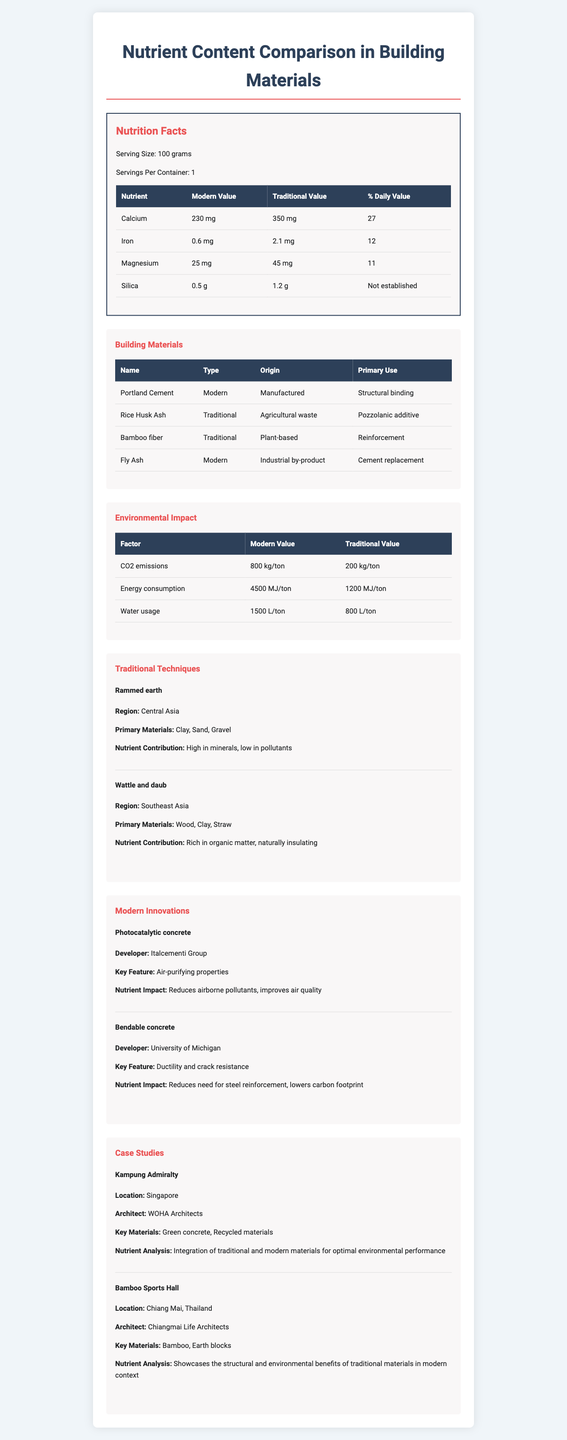what is the serving size mentioned in the document? The serving size is explicitly listed as "100 grams" in the Nutrition Facts section of the document.
Answer: 100 grams how many nutrients are compared between modern and traditional building materials? The document lists Calcium, Iron, Magnesium, and Silica in the Nutrition Facts section, making a total of four nutrients.
Answer: Four which traditional technique is high in minerals and low in pollutants? The Traditional Techniques section describes Rammed earth as high in minerals and low in pollutants.
Answer: Rammed earth what is the primary use of Portland Cement? The Building Materials section states that Portland Cement's primary use is for structural binding.
Answer: Structural binding how does photocatalytic concrete impact nutrients? The Modern Innovations section describes photocatalytic concrete's nutrient impact as reducing airborne pollutants and improving air quality.
Answer: Reduces airborne pollutants, improves air quality what are the primary materials used in the wattle and daub technique? A. Clay, Sand, Gravel B. Wood, Clay, Straw C. Straw, Sand, Earth D. Bamboo, Earth, Metal The Traditional Techniques section lists Wood, Clay, and Straw as the primary materials for the wattle and daub technique.
Answer: B. Wood, Clay, Straw what is the environmental impact of traditional materials concerning CO2 emissions? A. 800 kg/ton B. 4500 MJ/ton C. 1200 kg/ton D. 200 kg/ton The Environmental Impact section lists 200 kg/ton as the CO2 emissions value for traditional materials.
Answer: D. 200 kg/ton is fly ash considered a modern or traditional building material? The Building Materials section categorizes Fly Ash as a modern building material.
Answer: Modern does the document provide specific nutrient values for the case studies' key materials? The Case Studies section does not provide specific nutrient values for the key materials used; it focuses on the general analysis and integration of traditional and modern materials.
Answer: No summarize the main idea of the document. The document offers an in-depth look at the nutrient content and environmental impact of both modern and traditional building materials. It lists detailed nutrient values, origins, and uses of several materials, compares environmental impacts, examines traditional building techniques, modern innovations, and includes case studies to highlight practical applications and benefits.
Answer: The document provides a comparative analysis of nutrient content, environmental impact, and usage between modern and traditional building materials in Asian architecture. It details the nutrient values of various materials, examines different building techniques, and presents case studies showcasing the application and benefits of these materials. how much magnesium is found in traditional materials? The Nutrition Facts section lists the magnesium content for traditional materials as 45 mg per 100 grams.
Answer: 45 mg which material has the highest daily value percentage of calcium? A. Fly Ash B. Portland Cement C. Rice Husk Ash D. Bamboo fiber In the Nutrition Facts section, Rice Husk Ash has the highest daily value percentage of calcium at 27%.
Answer: C. Rice Husk Ash is it possible to determine the specific developer of bendable concrete from the document? The Modern Innovations section states that the University of Michigan developed bendable concrete.
Answer: Yes 